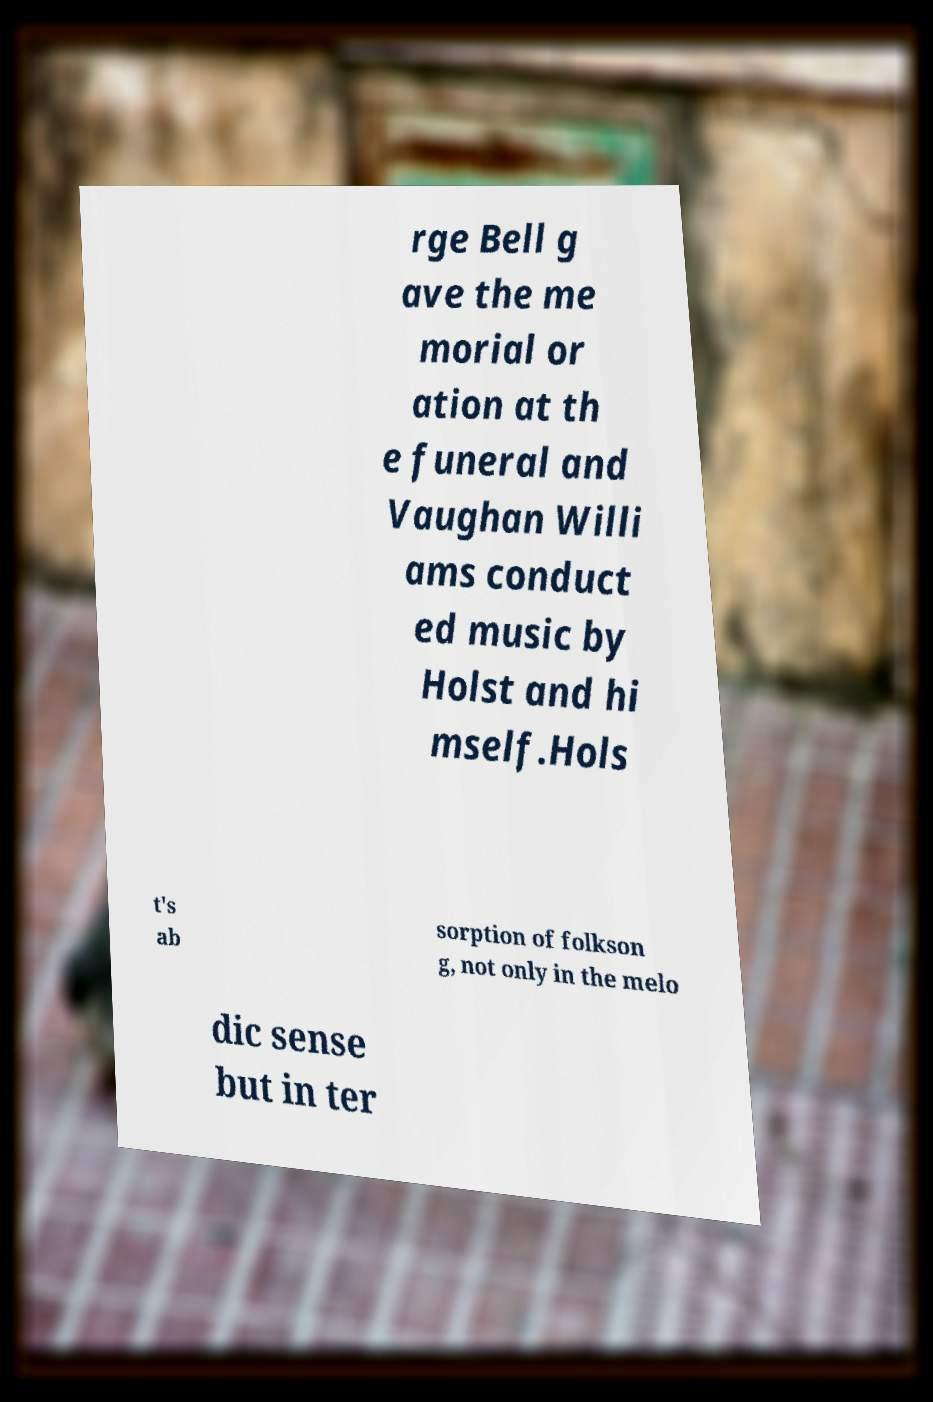Can you read and provide the text displayed in the image?This photo seems to have some interesting text. Can you extract and type it out for me? rge Bell g ave the me morial or ation at th e funeral and Vaughan Willi ams conduct ed music by Holst and hi mself.Hols t's ab sorption of folkson g, not only in the melo dic sense but in ter 